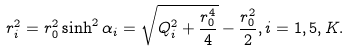Convert formula to latex. <formula><loc_0><loc_0><loc_500><loc_500>r _ { i } ^ { 2 } = r _ { 0 } ^ { 2 } \sinh ^ { 2 } \alpha _ { i } = \sqrt { Q _ { i } ^ { 2 } + { \frac { r _ { 0 } ^ { 4 } } { 4 } } } - { \frac { r _ { 0 } ^ { 2 } } { 2 } } , i = 1 , 5 , K .</formula> 